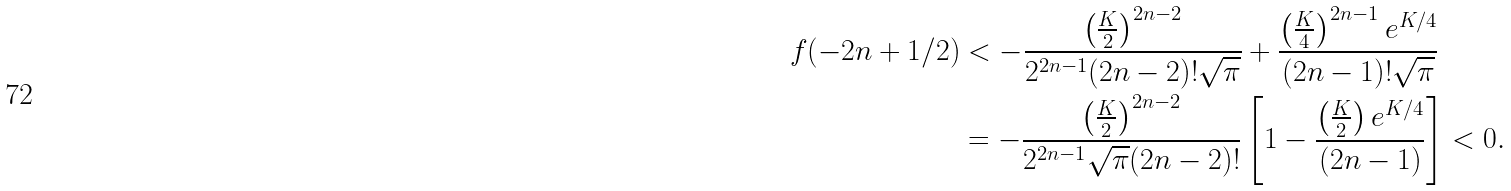Convert formula to latex. <formula><loc_0><loc_0><loc_500><loc_500>f ( - 2 n + 1 / 2 ) & < - \frac { \left ( \frac { K } { 2 } \right ) ^ { 2 n - 2 } } { 2 ^ { 2 n - 1 } ( 2 n - 2 ) ! \sqrt { \pi } } + \frac { \left ( \frac { K } { 4 } \right ) ^ { 2 n - 1 } e ^ { K / 4 } } { ( 2 n - 1 ) ! \sqrt { \pi } } \\ & = - \frac { \left ( \frac { K } { 2 } \right ) ^ { 2 n - 2 } } { 2 ^ { 2 n - 1 } \sqrt { \pi } ( 2 n - 2 ) ! } \left [ 1 - \frac { \left ( \frac { K } { 2 } \right ) e ^ { K / 4 } } { ( 2 n - 1 ) } \right ] < 0 .</formula> 